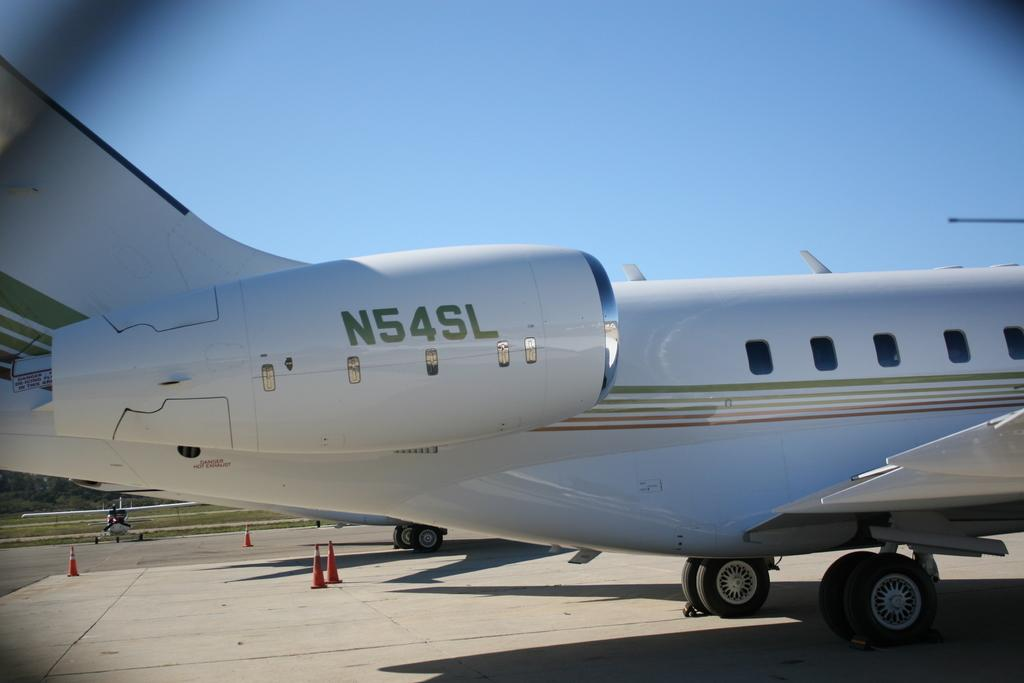What type of vehicles are on the road in the image? There are aircrafts on the road in the image. What safety measures are present near the road? Traffic cones are visible near the road. What type of vegetation is near the road? There is grass near the road. What can be seen in the background of the image? There are many trees and the sky is visible in the background. Where is the hydrant located in the image? There is no hydrant present in the image. What type of mountain can be seen in the background? There are no mountains visible in the image; only trees and the sky are present in the background. 